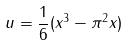<formula> <loc_0><loc_0><loc_500><loc_500>u = \frac { 1 } { 6 } ( x ^ { 3 } - \pi ^ { 2 } x )</formula> 